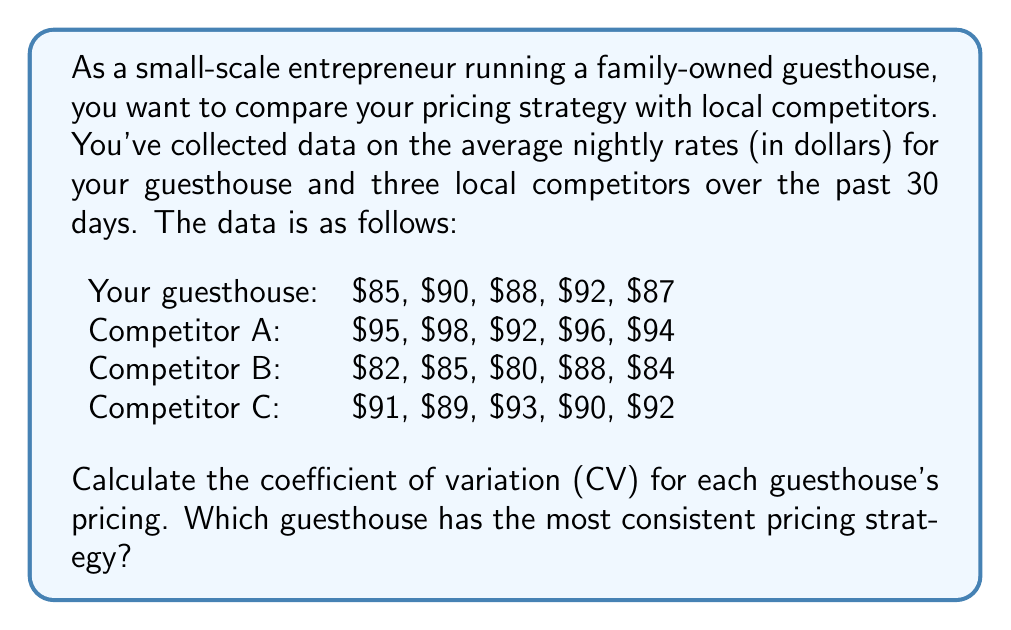Solve this math problem. To solve this problem, we need to follow these steps for each guesthouse:

1. Calculate the mean price
2. Calculate the standard deviation
3. Calculate the coefficient of variation (CV)

The coefficient of variation is given by the formula:

$$ CV = \frac{\sigma}{\mu} \times 100\% $$

Where $\sigma$ is the standard deviation and $\mu$ is the mean.

Let's calculate for each guesthouse:

Your guesthouse:
Mean: $\mu = \frac{85 + 90 + 88 + 92 + 87}{5} = 88.4$
Standard deviation: $\sigma = \sqrt{\frac{\sum(x - \mu)^2}{n-1}} = 2.7019$
CV: $\frac{2.7019}{88.4} \times 100\% = 3.06\%$

Competitor A:
Mean: $\mu = 95$
Standard deviation: $\sigma = 2.2361$
CV: $\frac{2.2361}{95} \times 100\% = 2.35\%$

Competitor B:
Mean: $\mu = 83.8$
Standard deviation: $\sigma = 3.0332$
CV: $\frac{3.0332}{83.8} \times 100\% = 3.62\%$

Competitor C:
Mean: $\mu = 91$
Standard deviation: $\sigma = 1.5811$
CV: $\frac{1.5811}{91} \times 100\% = 1.74\%$

The lowest CV indicates the most consistent pricing strategy.
Answer: Competitor C has the most consistent pricing strategy with a CV of 1.74%. 